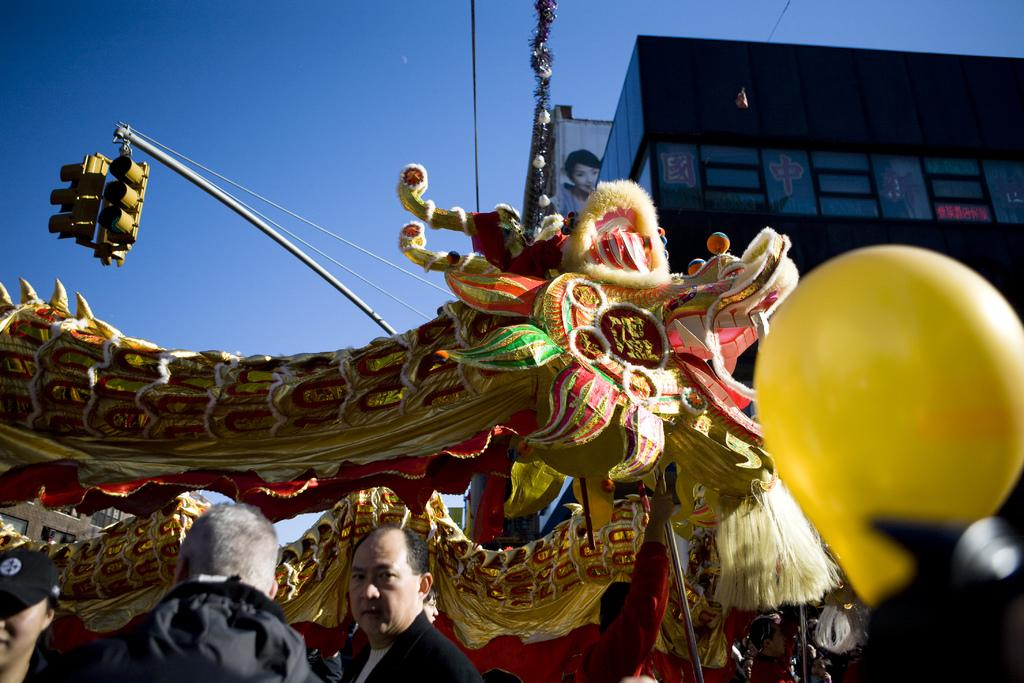What mythical creature is present in the image? There is a dragon in the image. Who else is present in the image besides the dragon? There are people in the image. What can be seen in the background of the image? There is a building and a pole in the background of the image. What is the purpose of the pole in the image? The pole has signal lights on it, which suggests it is used for traffic control. What is the color of the sky in the image? The sky is blue in the image. Can you tell me how many goldfish are swimming in the dragon's mouth in the image? There are no goldfish present in the image, and the dragon's mouth is not depicted. What type of memory is being tested by the people in the image? There is no indication in the image that the people are participating in a memory test or any other activity related to memory. 